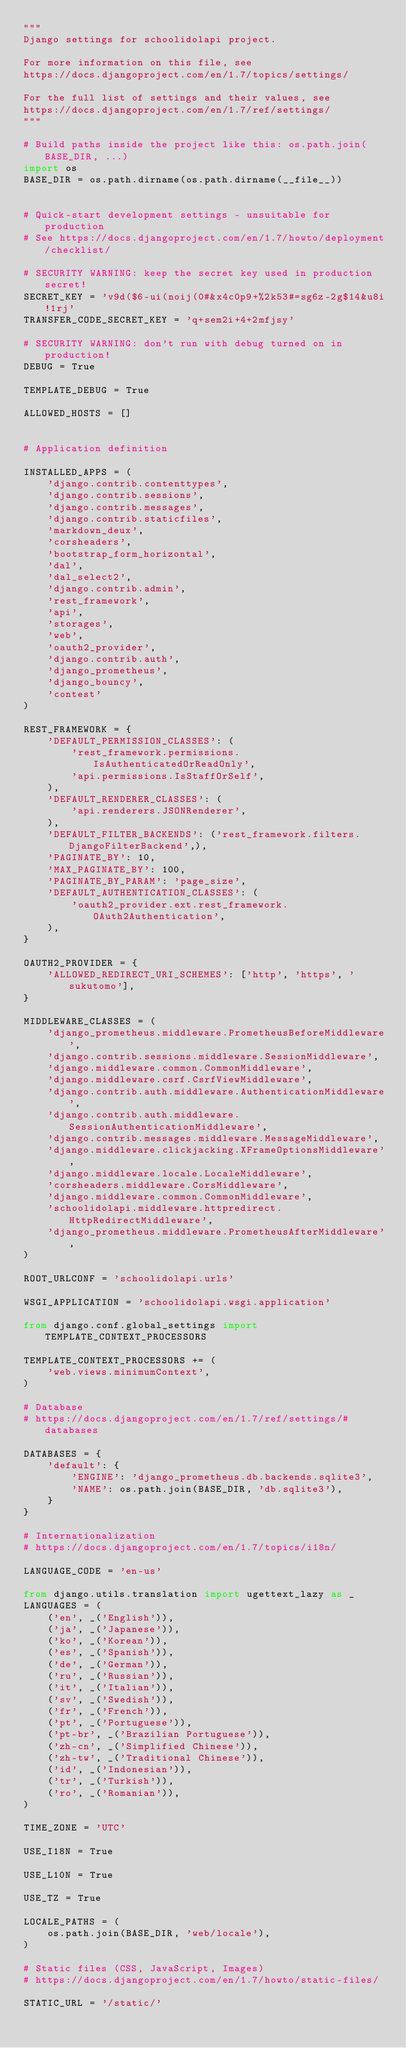<code> <loc_0><loc_0><loc_500><loc_500><_Python_>"""
Django settings for schoolidolapi project.

For more information on this file, see
https://docs.djangoproject.com/en/1.7/topics/settings/

For the full list of settings and their values, see
https://docs.djangoproject.com/en/1.7/ref/settings/
"""

# Build paths inside the project like this: os.path.join(BASE_DIR, ...)
import os
BASE_DIR = os.path.dirname(os.path.dirname(__file__))


# Quick-start development settings - unsuitable for production
# See https://docs.djangoproject.com/en/1.7/howto/deployment/checklist/

# SECURITY WARNING: keep the secret key used in production secret!
SECRET_KEY = 'v9d($6-ui(noij(0#&x4c0p9+%2k53#=sg6z-2g$14&u8i!1rj'
TRANSFER_CODE_SECRET_KEY = 'q+sem2i+4+2mfjsy'

# SECURITY WARNING: don't run with debug turned on in production!
DEBUG = True

TEMPLATE_DEBUG = True

ALLOWED_HOSTS = []


# Application definition

INSTALLED_APPS = (
    'django.contrib.contenttypes',
    'django.contrib.sessions',
    'django.contrib.messages',
    'django.contrib.staticfiles',
    'markdown_deux',
    'corsheaders',
    'bootstrap_form_horizontal',
    'dal',
    'dal_select2',
    'django.contrib.admin',
    'rest_framework',
    'api',
    'storages',
    'web',
    'oauth2_provider',
    'django.contrib.auth',
    'django_prometheus',
    'django_bouncy',
    'contest'
)

REST_FRAMEWORK = {
    'DEFAULT_PERMISSION_CLASSES': (
        'rest_framework.permissions.IsAuthenticatedOrReadOnly',
        'api.permissions.IsStaffOrSelf',
    ),
    'DEFAULT_RENDERER_CLASSES': (
        'api.renderers.JSONRenderer',
    ),
    'DEFAULT_FILTER_BACKENDS': ('rest_framework.filters.DjangoFilterBackend',),
    'PAGINATE_BY': 10,
    'MAX_PAGINATE_BY': 100,
    'PAGINATE_BY_PARAM': 'page_size',
    'DEFAULT_AUTHENTICATION_CLASSES': (
        'oauth2_provider.ext.rest_framework.OAuth2Authentication',
    ),
}

OAUTH2_PROVIDER = {
    'ALLOWED_REDIRECT_URI_SCHEMES': ['http', 'https', 'sukutomo'],
}

MIDDLEWARE_CLASSES = (
    'django_prometheus.middleware.PrometheusBeforeMiddleware',
    'django.contrib.sessions.middleware.SessionMiddleware',
    'django.middleware.common.CommonMiddleware',
    'django.middleware.csrf.CsrfViewMiddleware',
    'django.contrib.auth.middleware.AuthenticationMiddleware',
    'django.contrib.auth.middleware.SessionAuthenticationMiddleware',
    'django.contrib.messages.middleware.MessageMiddleware',
    'django.middleware.clickjacking.XFrameOptionsMiddleware',
    'django.middleware.locale.LocaleMiddleware',
    'corsheaders.middleware.CorsMiddleware',
    'django.middleware.common.CommonMiddleware',
    'schoolidolapi.middleware.httpredirect.HttpRedirectMiddleware',
    'django_prometheus.middleware.PrometheusAfterMiddleware',
)

ROOT_URLCONF = 'schoolidolapi.urls'

WSGI_APPLICATION = 'schoolidolapi.wsgi.application'

from django.conf.global_settings import TEMPLATE_CONTEXT_PROCESSORS

TEMPLATE_CONTEXT_PROCESSORS += (
    'web.views.minimumContext',
)

# Database
# https://docs.djangoproject.com/en/1.7/ref/settings/#databases

DATABASES = {
    'default': {
        'ENGINE': 'django_prometheus.db.backends.sqlite3',
        'NAME': os.path.join(BASE_DIR, 'db.sqlite3'),
    }
}

# Internationalization
# https://docs.djangoproject.com/en/1.7/topics/i18n/

LANGUAGE_CODE = 'en-us'

from django.utils.translation import ugettext_lazy as _
LANGUAGES = (
    ('en', _('English')),
    ('ja', _('Japanese')),
    ('ko', _('Korean')),
    ('es', _('Spanish')),
    ('de', _('German')),
    ('ru', _('Russian')),
    ('it', _('Italian')),
    ('sv', _('Swedish')),
    ('fr', _('French')),
    ('pt', _('Portuguese')),
    ('pt-br', _('Brazilian Portuguese')),
    ('zh-cn', _('Simplified Chinese')),
    ('zh-tw', _('Traditional Chinese')),
    ('id', _('Indonesian')),
    ('tr', _('Turkish')),
    ('ro', _('Romanian')),
)

TIME_ZONE = 'UTC'

USE_I18N = True

USE_L10N = True

USE_TZ = True

LOCALE_PATHS = (
    os.path.join(BASE_DIR, 'web/locale'),
)

# Static files (CSS, JavaScript, Images)
# https://docs.djangoproject.com/en/1.7/howto/static-files/

STATIC_URL = '/static/'
</code> 